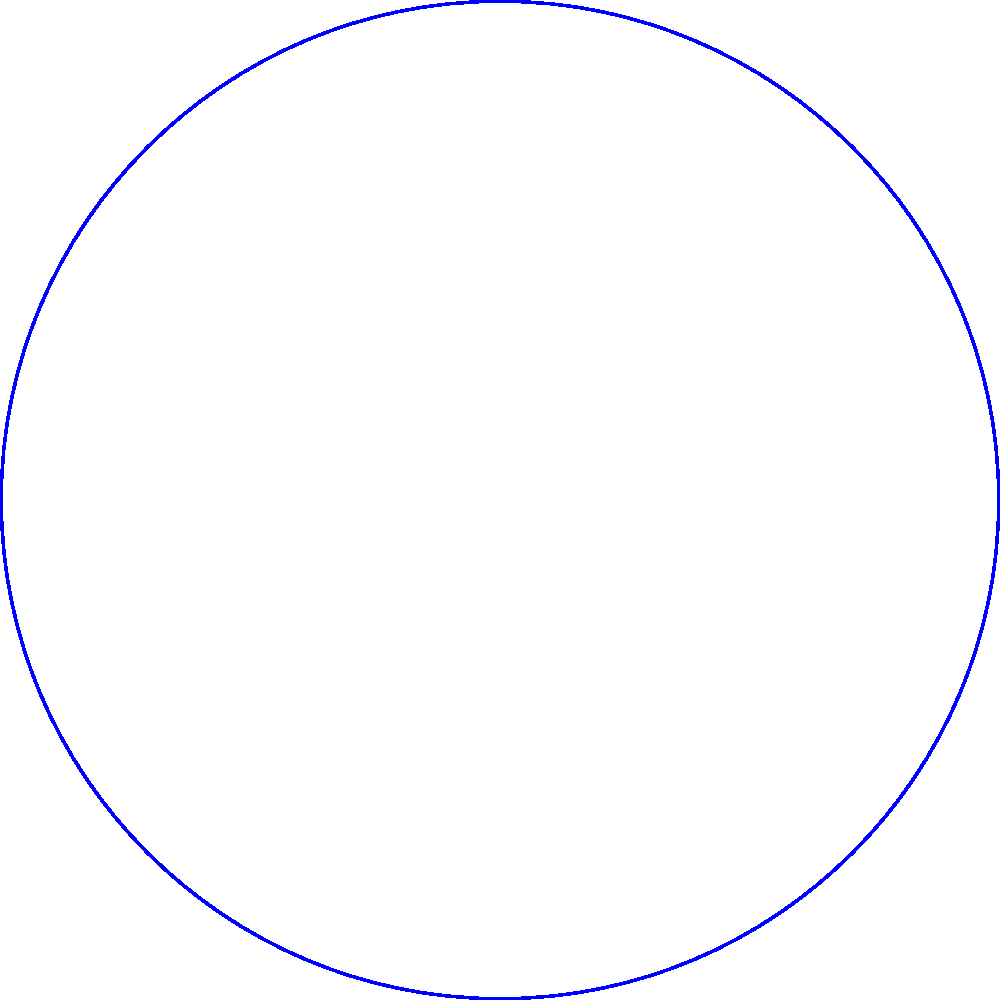Given two satellites with coverage areas represented in polar coordinates:

Satellite 1: centered at $(1, 0)$ with radius $3$
Satellite 2: centered at $(2, \frac{\pi}{3})$ with radius $2.5$

Calculate the distance between the centers of the two coverage areas to determine if they overlap. Round your answer to two decimal places. To determine if the coverage areas overlap, we need to calculate the distance between their centers and compare it to the sum of their radii.

Step 1: Convert the polar coordinates to Cartesian coordinates.
Satellite 1: $(x_1, y_1) = (1, 0)$
Satellite 2: $(x_2, y_2) = (2 \cos(\frac{\pi}{3}), 2 \sin(\frac{\pi}{3}))$

Step 2: Calculate $x_2$ and $y_2$:
$x_2 = 2 \cos(\frac{\pi}{3}) = 2 \cdot \frac{1}{2} = 1$
$y_2 = 2 \sin(\frac{\pi}{3}) = 2 \cdot \frac{\sqrt{3}}{2} = \sqrt{3}$

Step 3: Use the distance formula to calculate the distance between the centers:
$d = \sqrt{(x_2 - x_1)^2 + (y_2 - y_1)^2}$
$d = \sqrt{(1 - 1)^2 + (\sqrt{3} - 0)^2}$
$d = \sqrt{0^2 + (\sqrt{3})^2}$
$d = \sqrt{3} \approx 1.73$

Step 4: Compare the distance to the sum of the radii:
Sum of radii = $3 + 2.5 = 5.5$

Since the distance between centers (1.73) is less than the sum of the radii (5.5), the coverage areas overlap.
Answer: $1.73$ 